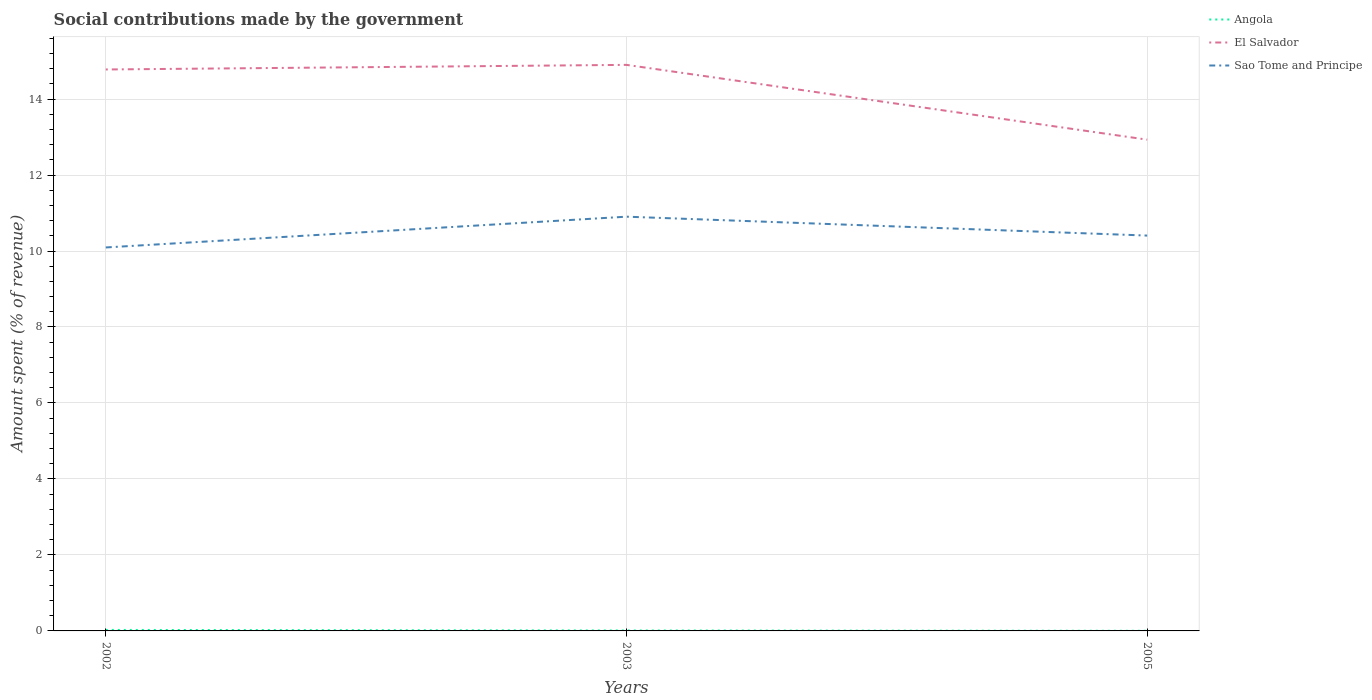Does the line corresponding to Angola intersect with the line corresponding to Sao Tome and Principe?
Offer a terse response. No. Is the number of lines equal to the number of legend labels?
Make the answer very short. Yes. Across all years, what is the maximum amount spent (in %) on social contributions in El Salvador?
Provide a succinct answer. 12.93. What is the total amount spent (in %) on social contributions in Sao Tome and Principe in the graph?
Keep it short and to the point. -0.81. What is the difference between the highest and the second highest amount spent (in %) on social contributions in El Salvador?
Give a very brief answer. 1.97. Is the amount spent (in %) on social contributions in El Salvador strictly greater than the amount spent (in %) on social contributions in Angola over the years?
Offer a very short reply. No. How many years are there in the graph?
Ensure brevity in your answer.  3. What is the difference between two consecutive major ticks on the Y-axis?
Give a very brief answer. 2. Does the graph contain any zero values?
Your answer should be compact. No. How many legend labels are there?
Provide a succinct answer. 3. How are the legend labels stacked?
Offer a very short reply. Vertical. What is the title of the graph?
Your answer should be very brief. Social contributions made by the government. What is the label or title of the Y-axis?
Your answer should be compact. Amount spent (% of revenue). What is the Amount spent (% of revenue) in Angola in 2002?
Offer a terse response. 0.03. What is the Amount spent (% of revenue) in El Salvador in 2002?
Provide a short and direct response. 14.78. What is the Amount spent (% of revenue) of Sao Tome and Principe in 2002?
Give a very brief answer. 10.09. What is the Amount spent (% of revenue) of Angola in 2003?
Offer a very short reply. 0.01. What is the Amount spent (% of revenue) of El Salvador in 2003?
Keep it short and to the point. 14.9. What is the Amount spent (% of revenue) in Sao Tome and Principe in 2003?
Your response must be concise. 10.9. What is the Amount spent (% of revenue) of Angola in 2005?
Ensure brevity in your answer.  0. What is the Amount spent (% of revenue) of El Salvador in 2005?
Make the answer very short. 12.93. What is the Amount spent (% of revenue) in Sao Tome and Principe in 2005?
Offer a very short reply. 10.41. Across all years, what is the maximum Amount spent (% of revenue) in Angola?
Your answer should be compact. 0.03. Across all years, what is the maximum Amount spent (% of revenue) of El Salvador?
Ensure brevity in your answer.  14.9. Across all years, what is the maximum Amount spent (% of revenue) in Sao Tome and Principe?
Your answer should be compact. 10.9. Across all years, what is the minimum Amount spent (% of revenue) of Angola?
Ensure brevity in your answer.  0. Across all years, what is the minimum Amount spent (% of revenue) of El Salvador?
Offer a very short reply. 12.93. Across all years, what is the minimum Amount spent (% of revenue) of Sao Tome and Principe?
Ensure brevity in your answer.  10.09. What is the total Amount spent (% of revenue) of Angola in the graph?
Your answer should be very brief. 0.04. What is the total Amount spent (% of revenue) of El Salvador in the graph?
Offer a terse response. 42.61. What is the total Amount spent (% of revenue) of Sao Tome and Principe in the graph?
Provide a succinct answer. 31.4. What is the difference between the Amount spent (% of revenue) in Angola in 2002 and that in 2003?
Make the answer very short. 0.02. What is the difference between the Amount spent (% of revenue) of El Salvador in 2002 and that in 2003?
Provide a short and direct response. -0.12. What is the difference between the Amount spent (% of revenue) of Sao Tome and Principe in 2002 and that in 2003?
Offer a terse response. -0.81. What is the difference between the Amount spent (% of revenue) of Angola in 2002 and that in 2005?
Keep it short and to the point. 0.02. What is the difference between the Amount spent (% of revenue) in El Salvador in 2002 and that in 2005?
Give a very brief answer. 1.85. What is the difference between the Amount spent (% of revenue) of Sao Tome and Principe in 2002 and that in 2005?
Offer a very short reply. -0.31. What is the difference between the Amount spent (% of revenue) in Angola in 2003 and that in 2005?
Give a very brief answer. 0.01. What is the difference between the Amount spent (% of revenue) of El Salvador in 2003 and that in 2005?
Provide a short and direct response. 1.97. What is the difference between the Amount spent (% of revenue) of Sao Tome and Principe in 2003 and that in 2005?
Keep it short and to the point. 0.5. What is the difference between the Amount spent (% of revenue) in Angola in 2002 and the Amount spent (% of revenue) in El Salvador in 2003?
Keep it short and to the point. -14.87. What is the difference between the Amount spent (% of revenue) of Angola in 2002 and the Amount spent (% of revenue) of Sao Tome and Principe in 2003?
Give a very brief answer. -10.88. What is the difference between the Amount spent (% of revenue) in El Salvador in 2002 and the Amount spent (% of revenue) in Sao Tome and Principe in 2003?
Provide a short and direct response. 3.87. What is the difference between the Amount spent (% of revenue) of Angola in 2002 and the Amount spent (% of revenue) of El Salvador in 2005?
Offer a terse response. -12.9. What is the difference between the Amount spent (% of revenue) of Angola in 2002 and the Amount spent (% of revenue) of Sao Tome and Principe in 2005?
Give a very brief answer. -10.38. What is the difference between the Amount spent (% of revenue) in El Salvador in 2002 and the Amount spent (% of revenue) in Sao Tome and Principe in 2005?
Provide a succinct answer. 4.37. What is the difference between the Amount spent (% of revenue) of Angola in 2003 and the Amount spent (% of revenue) of El Salvador in 2005?
Your answer should be very brief. -12.92. What is the difference between the Amount spent (% of revenue) of Angola in 2003 and the Amount spent (% of revenue) of Sao Tome and Principe in 2005?
Your answer should be very brief. -10.4. What is the difference between the Amount spent (% of revenue) in El Salvador in 2003 and the Amount spent (% of revenue) in Sao Tome and Principe in 2005?
Make the answer very short. 4.49. What is the average Amount spent (% of revenue) of Angola per year?
Provide a succinct answer. 0.01. What is the average Amount spent (% of revenue) in El Salvador per year?
Make the answer very short. 14.2. What is the average Amount spent (% of revenue) in Sao Tome and Principe per year?
Keep it short and to the point. 10.47. In the year 2002, what is the difference between the Amount spent (% of revenue) in Angola and Amount spent (% of revenue) in El Salvador?
Provide a succinct answer. -14.75. In the year 2002, what is the difference between the Amount spent (% of revenue) in Angola and Amount spent (% of revenue) in Sao Tome and Principe?
Offer a very short reply. -10.07. In the year 2002, what is the difference between the Amount spent (% of revenue) in El Salvador and Amount spent (% of revenue) in Sao Tome and Principe?
Provide a succinct answer. 4.68. In the year 2003, what is the difference between the Amount spent (% of revenue) in Angola and Amount spent (% of revenue) in El Salvador?
Your answer should be very brief. -14.89. In the year 2003, what is the difference between the Amount spent (% of revenue) in Angola and Amount spent (% of revenue) in Sao Tome and Principe?
Your answer should be compact. -10.89. In the year 2003, what is the difference between the Amount spent (% of revenue) in El Salvador and Amount spent (% of revenue) in Sao Tome and Principe?
Ensure brevity in your answer.  4. In the year 2005, what is the difference between the Amount spent (% of revenue) of Angola and Amount spent (% of revenue) of El Salvador?
Your response must be concise. -12.93. In the year 2005, what is the difference between the Amount spent (% of revenue) in Angola and Amount spent (% of revenue) in Sao Tome and Principe?
Provide a short and direct response. -10.4. In the year 2005, what is the difference between the Amount spent (% of revenue) of El Salvador and Amount spent (% of revenue) of Sao Tome and Principe?
Provide a short and direct response. 2.52. What is the ratio of the Amount spent (% of revenue) of Angola in 2002 to that in 2003?
Offer a very short reply. 2.34. What is the ratio of the Amount spent (% of revenue) of Sao Tome and Principe in 2002 to that in 2003?
Your answer should be compact. 0.93. What is the ratio of the Amount spent (% of revenue) of Angola in 2002 to that in 2005?
Provide a succinct answer. 8.47. What is the ratio of the Amount spent (% of revenue) in Sao Tome and Principe in 2002 to that in 2005?
Provide a short and direct response. 0.97. What is the ratio of the Amount spent (% of revenue) of Angola in 2003 to that in 2005?
Your response must be concise. 3.61. What is the ratio of the Amount spent (% of revenue) in El Salvador in 2003 to that in 2005?
Provide a succinct answer. 1.15. What is the ratio of the Amount spent (% of revenue) in Sao Tome and Principe in 2003 to that in 2005?
Your answer should be compact. 1.05. What is the difference between the highest and the second highest Amount spent (% of revenue) of Angola?
Your answer should be compact. 0.02. What is the difference between the highest and the second highest Amount spent (% of revenue) in El Salvador?
Your answer should be compact. 0.12. What is the difference between the highest and the second highest Amount spent (% of revenue) of Sao Tome and Principe?
Offer a terse response. 0.5. What is the difference between the highest and the lowest Amount spent (% of revenue) of Angola?
Offer a very short reply. 0.02. What is the difference between the highest and the lowest Amount spent (% of revenue) in El Salvador?
Offer a terse response. 1.97. What is the difference between the highest and the lowest Amount spent (% of revenue) in Sao Tome and Principe?
Offer a terse response. 0.81. 